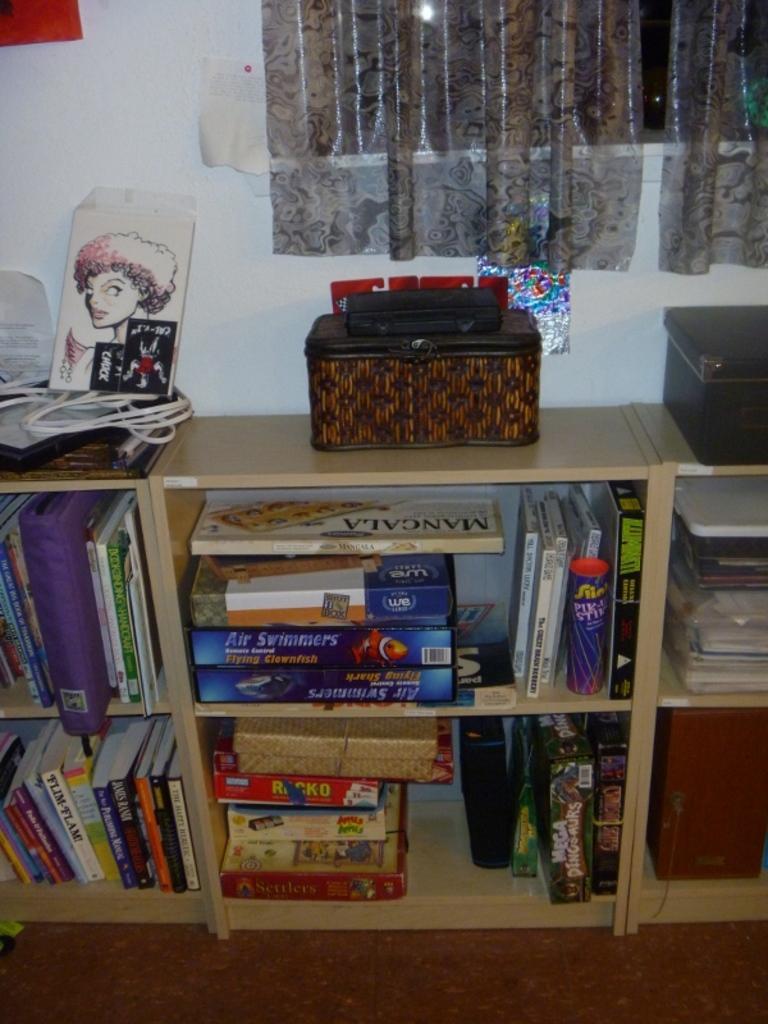Please provide a concise description of this image. This is the picture of a room. In the foreground there are books in the shelf and there are objects and there is a wire on the table. At the back there are curtains at the window and there are posters on the wall. At the bottom there is a floor. 